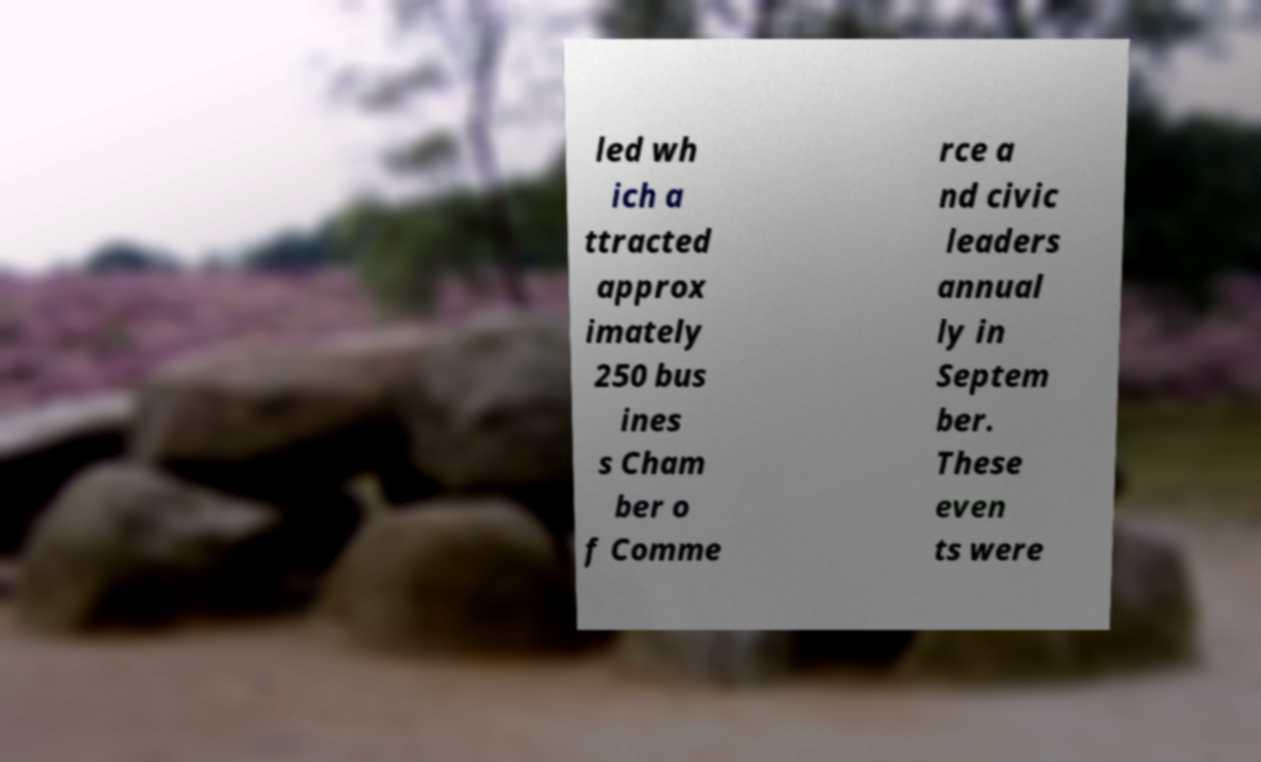There's text embedded in this image that I need extracted. Can you transcribe it verbatim? led wh ich a ttracted approx imately 250 bus ines s Cham ber o f Comme rce a nd civic leaders annual ly in Septem ber. These even ts were 